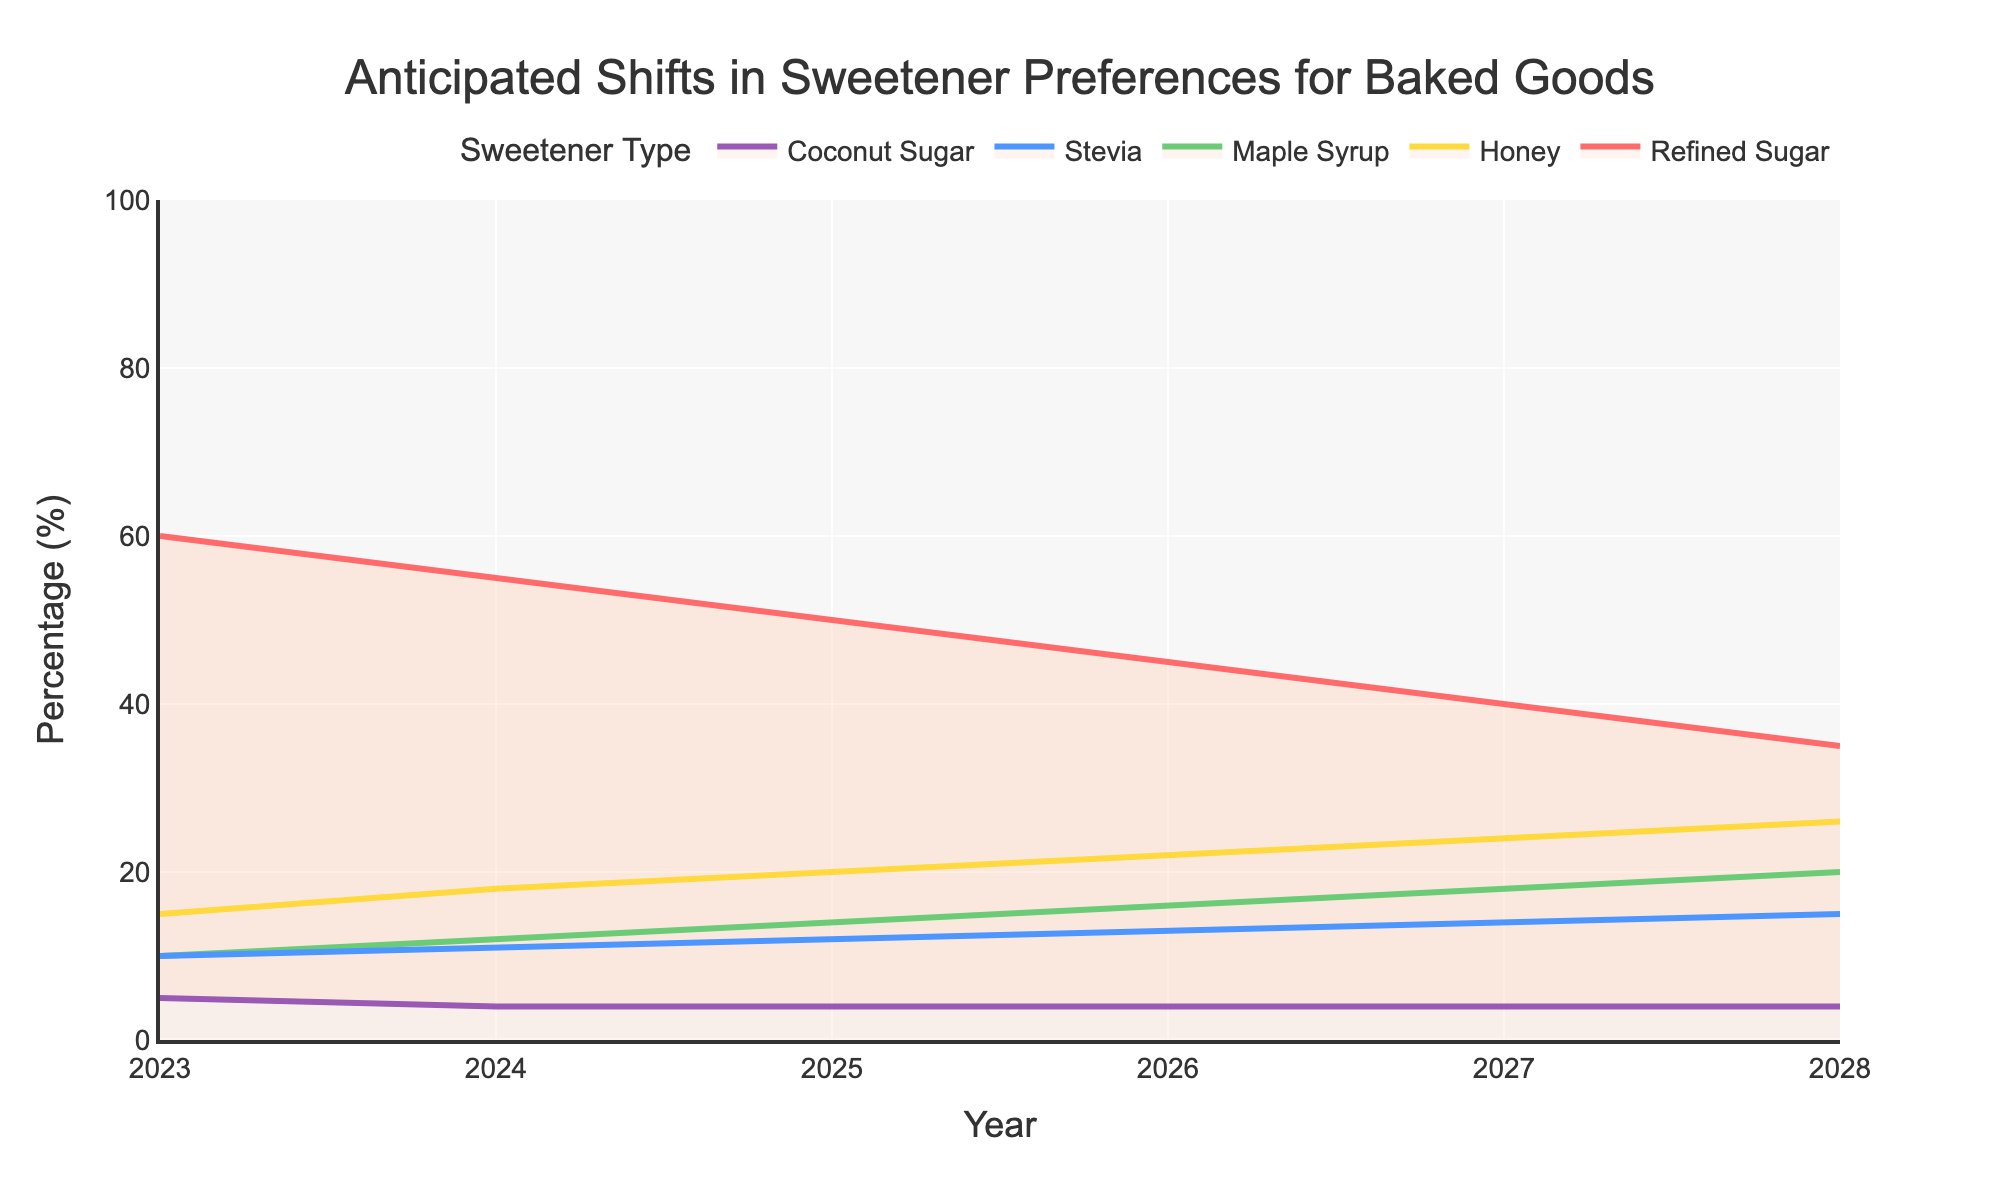What is the title of the chart? The title is usually at the top of the chart. Here, we can see the title "Anticipated Shifts in Sweetener Preferences for Baked Goods" prominently displayed.
Answer: Anticipated Shifts in Sweetener Preferences for Baked Goods Which sweetener is expected to have the highest percentage in 2023? Look at the y-values for the year 2023 across all sweeteners. Refined Sugar has the highest percentage, which is 60%.
Answer: Refined Sugar How does the percentage of Honey change from 2023 to 2028? Find the percentage value for Honey in 2023 and in 2028 and calculate the difference: 26% (2028) - 15% (2023) = 11%.
Answer: Increases by 11% In 2025, is the percentage of Stevia higher or lower than the percentage of Maple Syrup? Compare the percentages for Stevia and Maple Syrup in the year 2025. Stevia is at 12%, while Maple Syrup is at 14%.
Answer: Lower What is the total percentage of alternative sweeteners (excluding Refined Sugar) in 2026? Sum the percentages for Honey, Maple Syrup, Stevia, and Coconut Sugar in 2026: 22% + 16% + 13% + 4% = 55%.
Answer: 55% Which sweetener shows no percentage change from 2023 to 2028? Check if any sweetener's percentage remains constant over the years. Coconut Sugar remains at 4% throughout all years.
Answer: Coconut Sugar What trend do you notice for Refined Sugar from 2023 to 2028? Observe the trend line for Refined Sugar. It consistently decreases, from 60% in 2023 to 35% in 2028.
Answer: Decreasing Which year does Honey surpass 20% in consumer preference? Track the percentages for Honey over the years. It surpasses 20% in 2025.
Answer: 2025 If the percentage of Coconut Sugar remains constant, what would be its percentage in 2027? Since the percentage for Coconut Sugar remains constant at 4% from 2023 through 2028, it also will be 4% in 2027.
Answer: 4% Between which years does Stevia show the smallest increase in percentage? Calculate the difference in Stevia’s percentage for each year: 2023-2024 (1%), 2024-2025 (1%), 2025-2026 (1%), 2026-2027 (1%), 2027-2028 (1%). The increase remains constant each year.
Answer: All years (increments by 1%) 